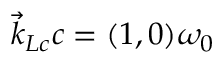Convert formula to latex. <formula><loc_0><loc_0><loc_500><loc_500>\vec { k } _ { L c } c = ( 1 , 0 ) \omega _ { 0 }</formula> 